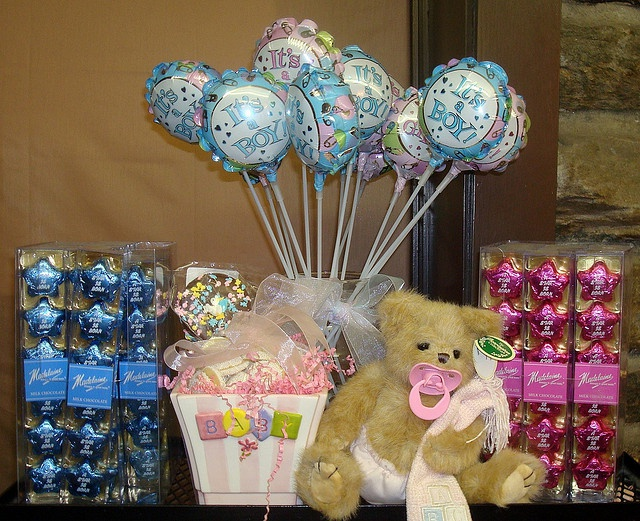Describe the objects in this image and their specific colors. I can see a teddy bear in brown, tan, olive, and lightpink tones in this image. 